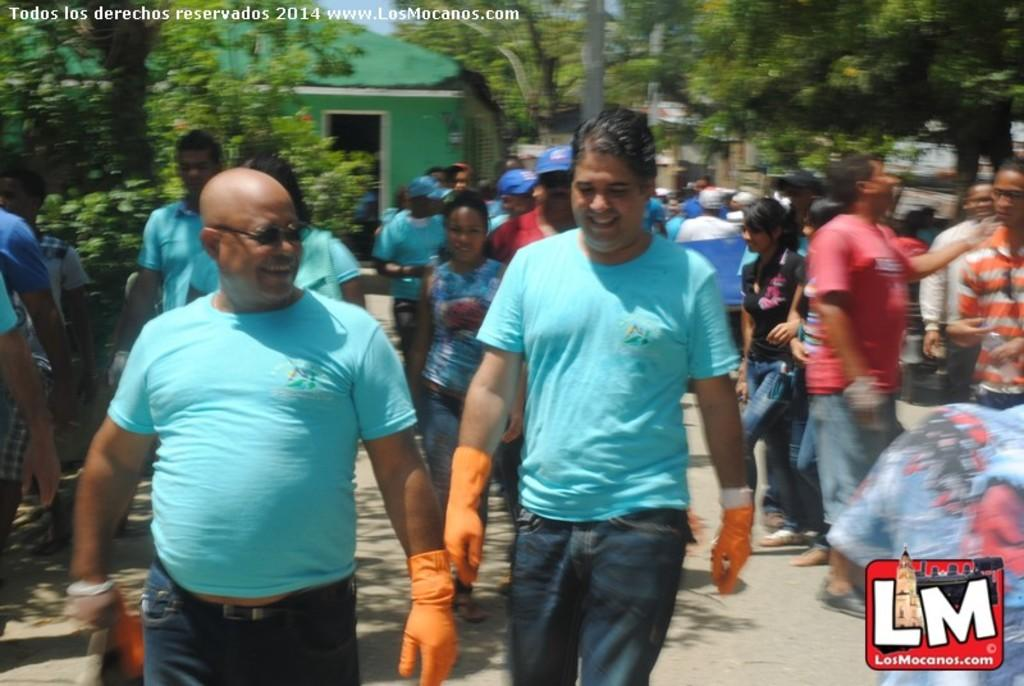What are the people in the image doing? The people in the image are walking and standing. Where are the people standing in the image? The people are standing on the right side of the image. What can be seen in the background of the image? There are trees visible in the image. What type of structure is present in the image? There is a house in the image. How many chairs can be seen in the image? There are no chairs visible in the image. What type of laughter can be heard coming from the people in the image? There is no indication of laughter in the image, as it only shows people walking and standing. 